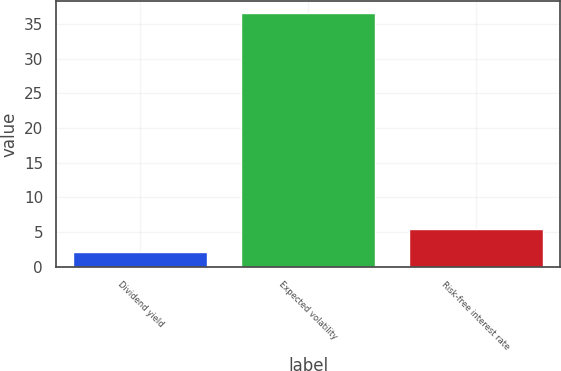Convert chart. <chart><loc_0><loc_0><loc_500><loc_500><bar_chart><fcel>Dividend yield<fcel>Expected volatility<fcel>Risk-free interest rate<nl><fcel>2.08<fcel>36.5<fcel>5.52<nl></chart> 